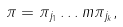<formula> <loc_0><loc_0><loc_500><loc_500>\pi = \pi _ { j _ { 1 } } \dots m \pi _ { j _ { k } } ,</formula> 